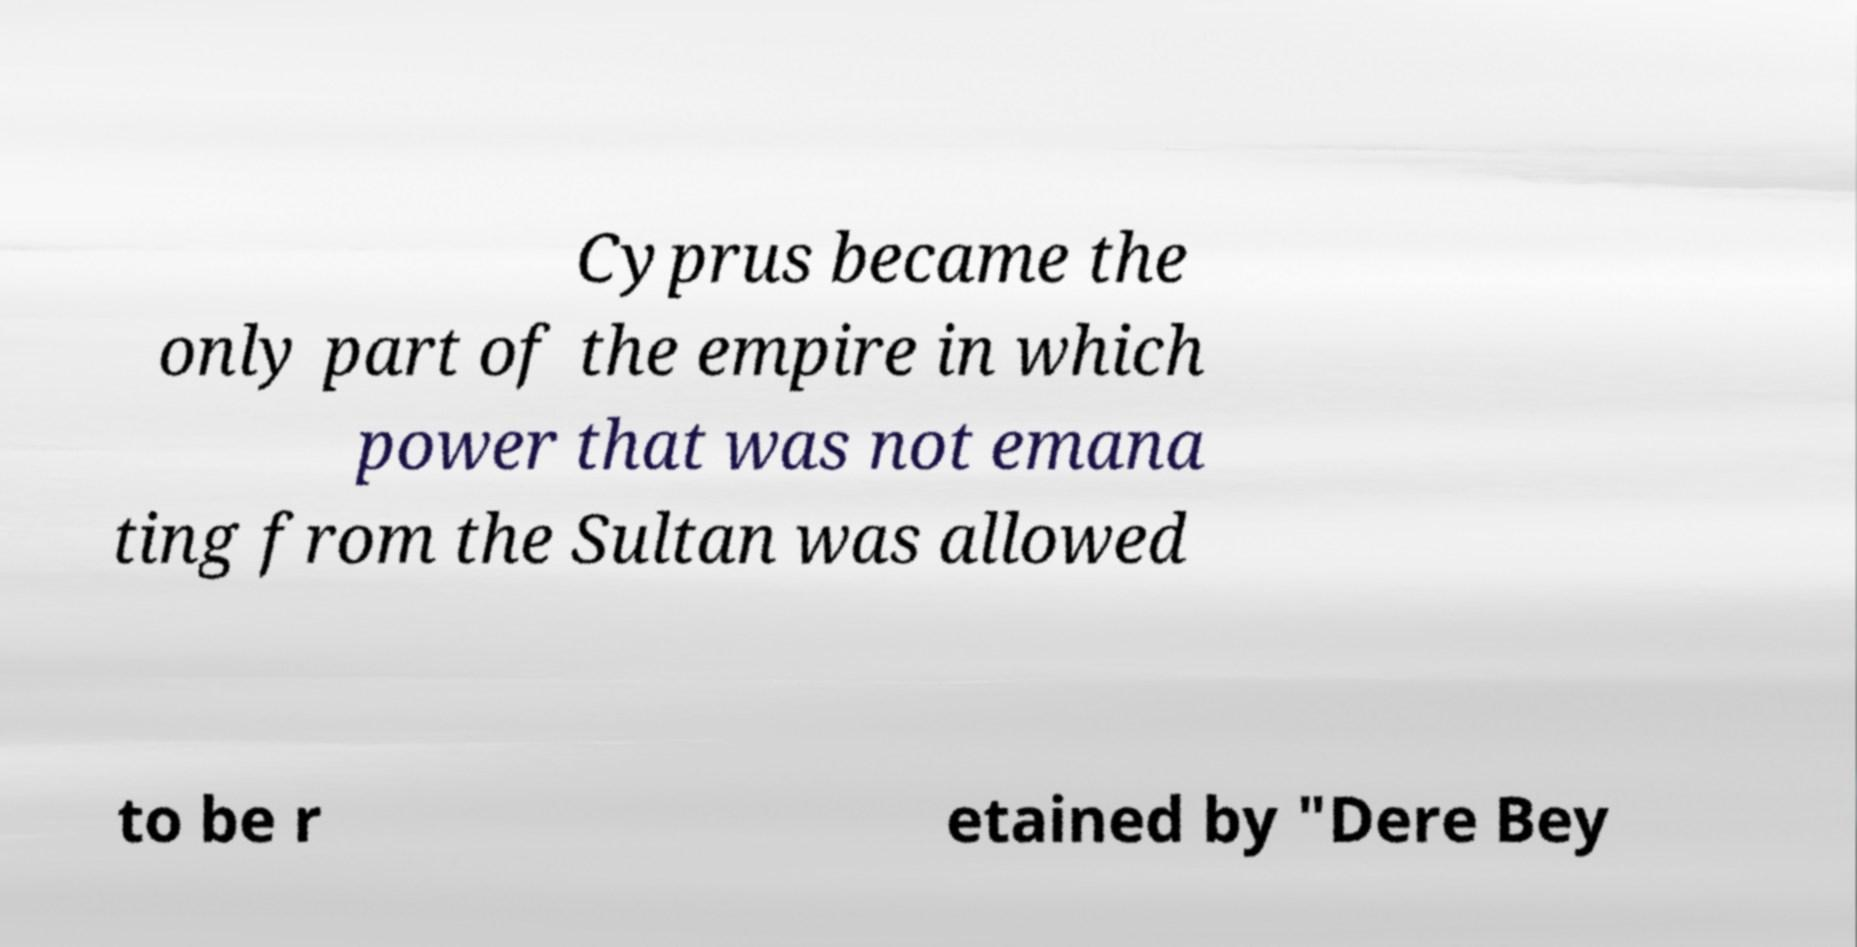For documentation purposes, I need the text within this image transcribed. Could you provide that? Cyprus became the only part of the empire in which power that was not emana ting from the Sultan was allowed to be r etained by "Dere Bey 